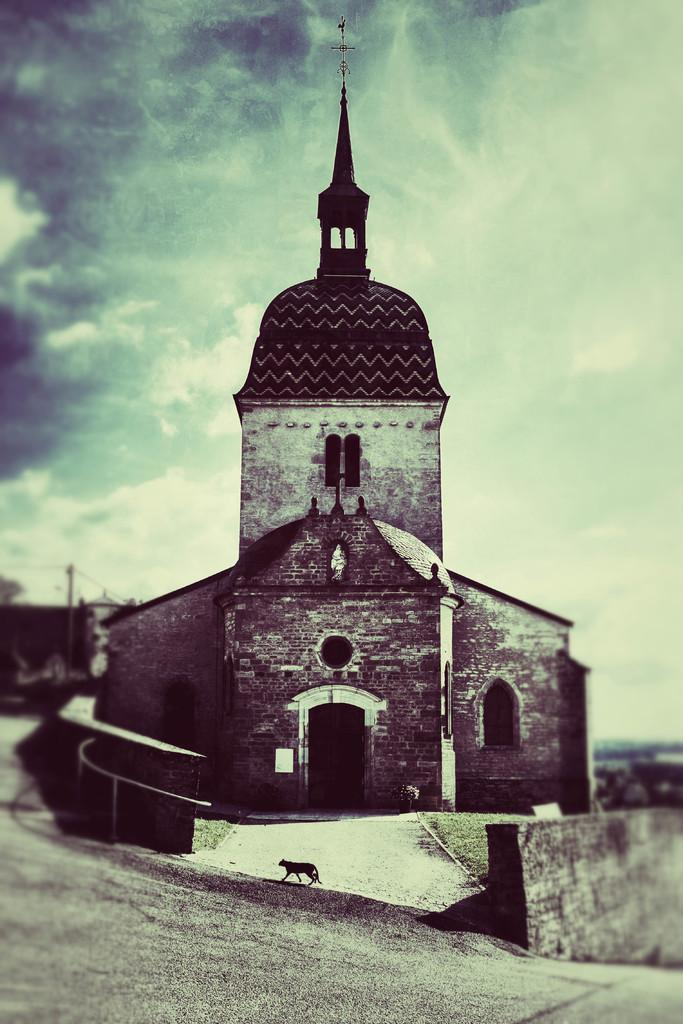What type of structure is visible in the image? There is a building in the image. Can you describe any specific features of the building? There is a window and a wall visible in the image. What is on the ground in the image? There is an animal on the ground in the image. How would you describe the weather in the image? The sky is cloudy in the image. What route is the animal following in the image? There is no indication of a specific route that the animal is following in the image. Is there any smoke visible in the image? There is no smoke present in the image. 